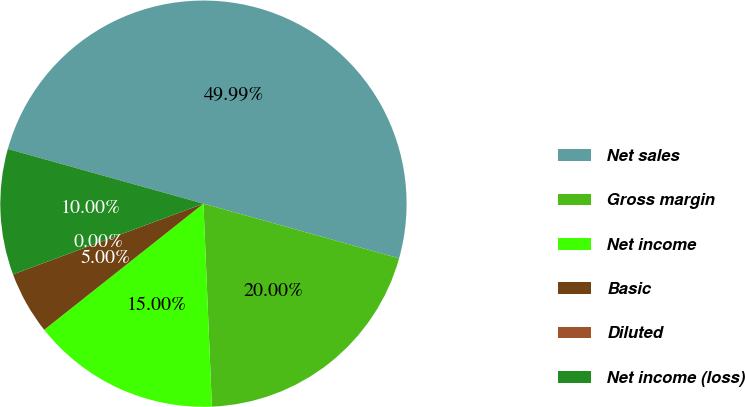Convert chart to OTSL. <chart><loc_0><loc_0><loc_500><loc_500><pie_chart><fcel>Net sales<fcel>Gross margin<fcel>Net income<fcel>Basic<fcel>Diluted<fcel>Net income (loss)<nl><fcel>49.99%<fcel>20.0%<fcel>15.0%<fcel>5.0%<fcel>0.0%<fcel>10.0%<nl></chart> 